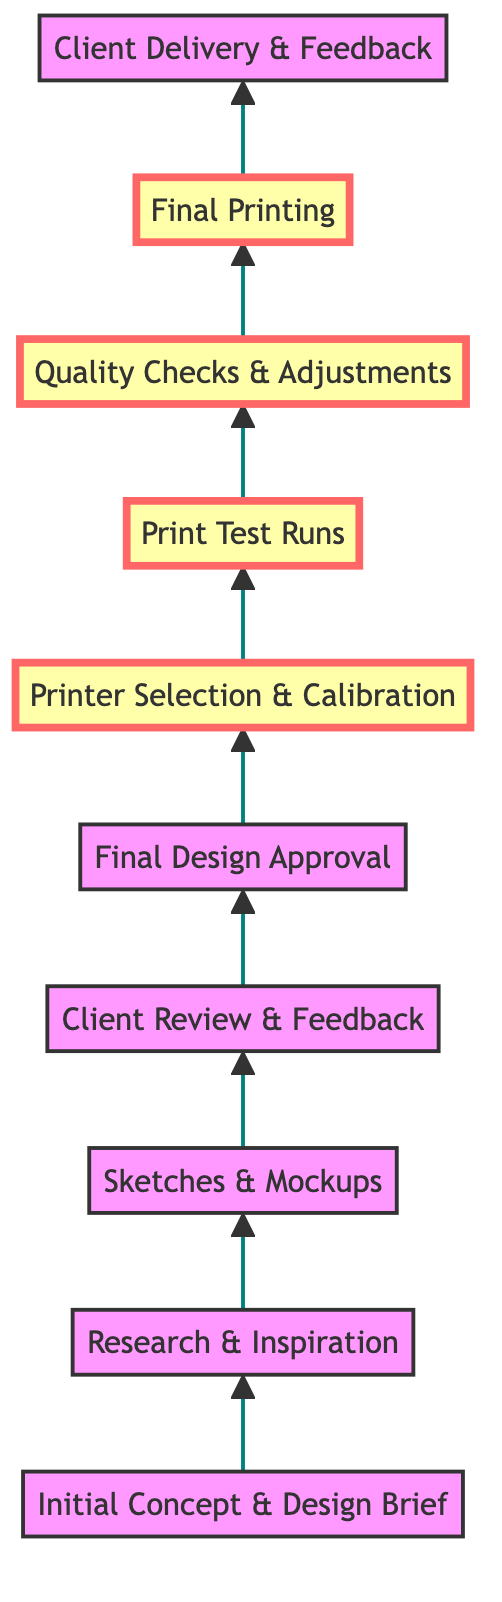What is the first step in the workflow? The first step, at the bottom of the flow chart, is "Initial Concept & Design Brief." It represents the starting point of the graphic design project workflow.
Answer: Initial Concept & Design Brief How many steps are there in the workflow? There are ten steps in the workflow, starting from "Initial Concept & Design Brief" and ending with "Client Delivery & Feedback." Each box represents a step in the process.
Answer: Ten Which step follows the "Client Review & Feedback"? The step that directly follows "Client Review & Feedback" is "Final Design Approval," indicating that after receiving feedback, the design needs to be finalized and approved by the client.
Answer: Final Design Approval What step involves selecting a color printer? The step that involves selecting a color printer is "Printer Selection & Calibration," where you choose a cost-effective printer and make adjustments for color accuracy.
Answer: Printer Selection & Calibration What is the last step in this workflow? The last step in the workflow is "Client Delivery & Feedback," which indicates that the printed product is delivered to the client for their feedback.
Answer: Client Delivery & Feedback Which steps are highlighted in the workflow, and why? The highlighted steps are "Printer Selection & Calibration," "Print Test Runs," and "Quality Checks & Adjustments." These steps are emphasized as critical parts of ensuring the quality and accuracy of the printing process.
Answer: Printer Selection & Calibration, Print Test Runs, Quality Checks & Adjustments What relationship exists between "Final Design Approval" and "Printer Selection & Calibration"? The relationship is sequential; "Final Design Approval" must occur before "Printer Selection & Calibration," as the design needs to be approved before a printer can be selected for printing.
Answer: Sequential relationship What is the purpose of "Quality Checks & Adjustments"? The purpose of "Quality Checks & Adjustments" is to evaluate the printed output for resolution, color accuracy, and clarity, ensuring the final product meets the expected standards.
Answer: Evaluate printed output Which node describes the gathering of visual inspiration? The node that describes gathering visual inspiration is "Research & Inspiration." This step focuses on collecting ideas and analyzing competitors to inform the design process.
Answer: Research & Inspiration How many highlighted steps are in the diagram? There are three highlighted steps in the diagram that focus on critical aspects of the printing process. These steps ensure that the design translates well into the final printed product.
Answer: Three 